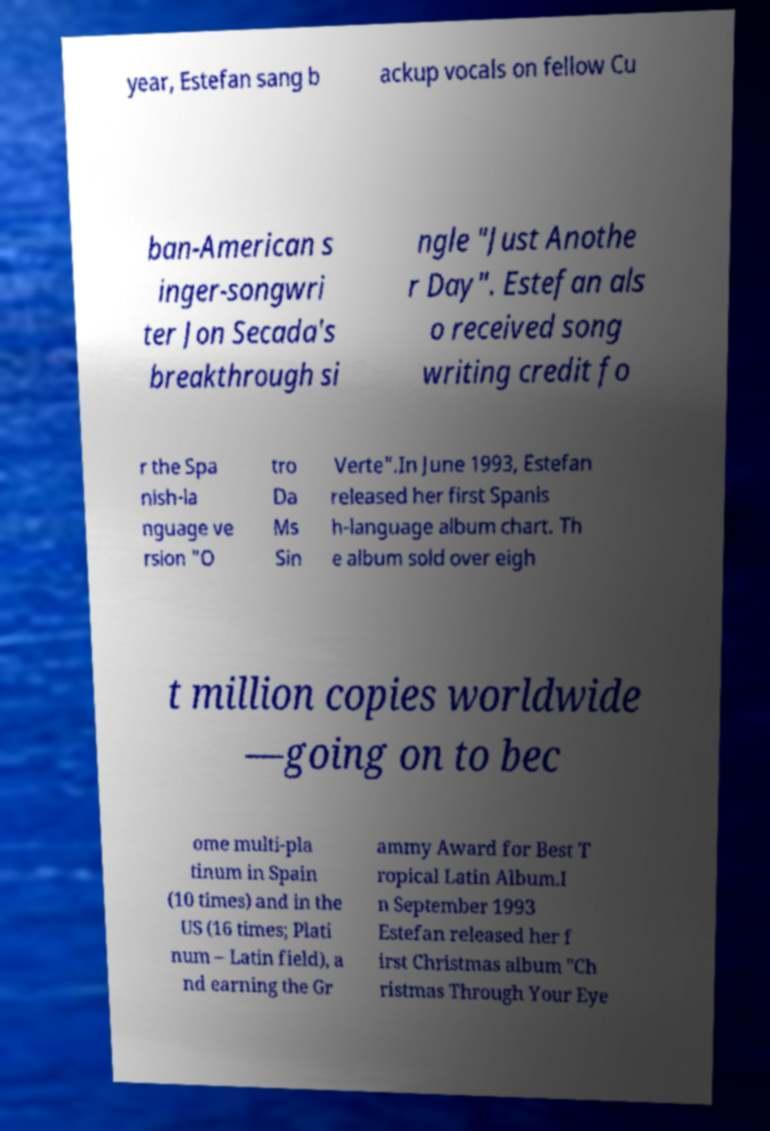Please read and relay the text visible in this image. What does it say? year, Estefan sang b ackup vocals on fellow Cu ban-American s inger-songwri ter Jon Secada's breakthrough si ngle "Just Anothe r Day". Estefan als o received song writing credit fo r the Spa nish-la nguage ve rsion "O tro Da Ms Sin Verte".In June 1993, Estefan released her first Spanis h-language album chart. Th e album sold over eigh t million copies worldwide —going on to bec ome multi-pla tinum in Spain (10 times) and in the US (16 times; Plati num – Latin field), a nd earning the Gr ammy Award for Best T ropical Latin Album.I n September 1993 Estefan released her f irst Christmas album "Ch ristmas Through Your Eye 